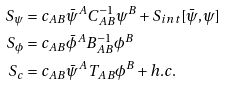<formula> <loc_0><loc_0><loc_500><loc_500>S _ { \psi } & = c _ { A B } \bar { \psi } ^ { A } C ^ { - 1 } _ { A B } \psi ^ { B } + S _ { i n t } [ \bar { \psi } , \psi ] \\ S _ { \phi } & = c _ { A B } \bar { \phi } ^ { A } B ^ { - 1 } _ { A B } \phi ^ { B } \\ S _ { c } & = c _ { A B } \bar { \psi } ^ { A } T _ { A B } \phi ^ { B } + h . c .</formula> 